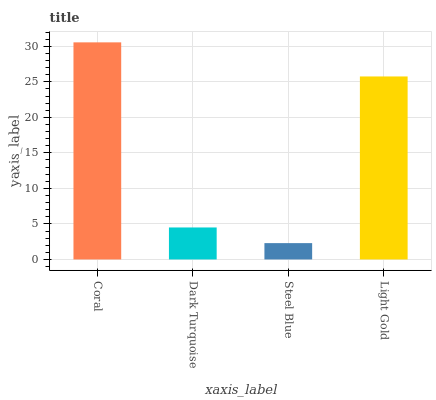Is Steel Blue the minimum?
Answer yes or no. Yes. Is Coral the maximum?
Answer yes or no. Yes. Is Dark Turquoise the minimum?
Answer yes or no. No. Is Dark Turquoise the maximum?
Answer yes or no. No. Is Coral greater than Dark Turquoise?
Answer yes or no. Yes. Is Dark Turquoise less than Coral?
Answer yes or no. Yes. Is Dark Turquoise greater than Coral?
Answer yes or no. No. Is Coral less than Dark Turquoise?
Answer yes or no. No. Is Light Gold the high median?
Answer yes or no. Yes. Is Dark Turquoise the low median?
Answer yes or no. Yes. Is Coral the high median?
Answer yes or no. No. Is Light Gold the low median?
Answer yes or no. No. 